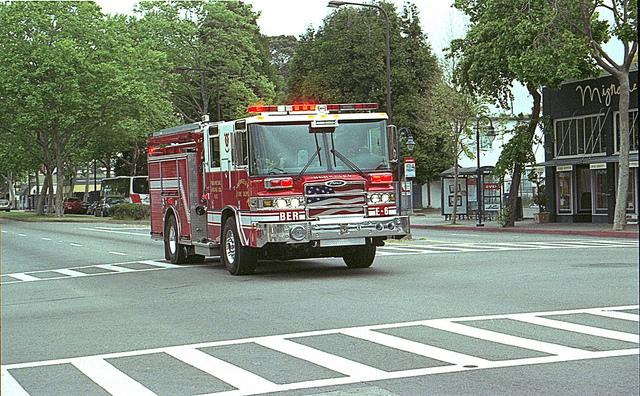What do the flashing lights indicate on this vehicle? Please explain your reasoning. fire. The lights indicate fire. 